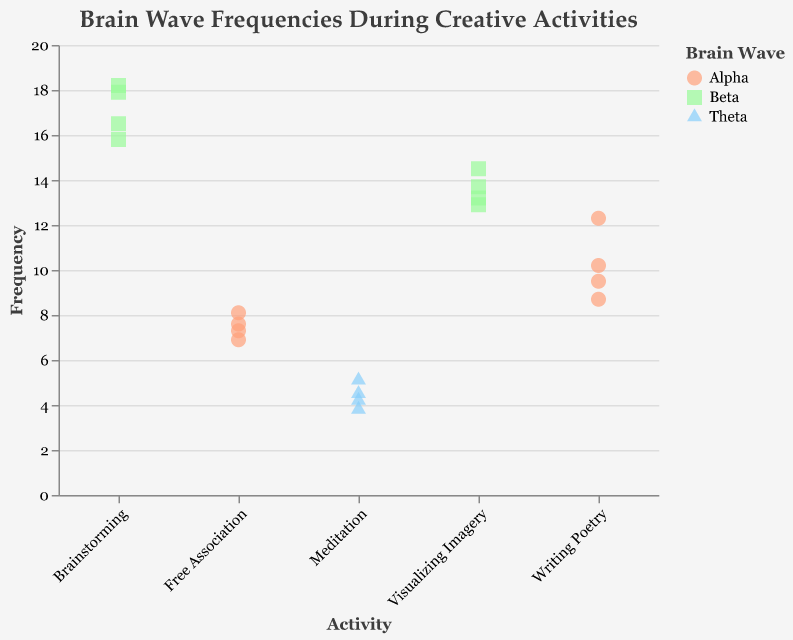What's the title of the figure? The title of the figure is typically found at the top and summarizes the main focus of the chart. Here, it reads "Brain Wave Frequencies During Creative Activities."
Answer: Brain Wave Frequencies During Creative Activities Which brain wave type is associated with the highest frequency during Brainstorming? By looking at the points plotted for Brainstorming, we can see the color and shape used for those points. The highest frequency is around 18.2, and these points are colored in green and are square-shaped. According to the legend, green squares represent Beta waves.
Answer: Beta How many data points are there in the activity Meditation? By counting the plotted points under the "Meditation" category on the x-axis, we can see there are four triangular points.
Answer: 4 Compare the average frequencies of Alpha waves in Writing Poetry and Free Association. Which activity has a lower average frequency of Alpha waves? First, calculate the average frequency for Writing Poetry ([10.2 + 8.7 + 12.3 + 9.5] / 4) and Free Association ([7.3 + 6.9 + 8.1 + 7.6] / 4). Writing Poetry average is (40.7 / 4) = 10.175; Free Association average is (29.9 / 4) = 7.475. Free Association has a lower average frequency.
Answer: Free Association What's the range of frequencies for the activity Visualizing Imagery? The range is the difference between the maximum and minimum values. The highest frequency for Visualizing Imagery is 14.5 and the lowest is 12.9. Thus, the range is 14.5 - 12.9.
Answer: 1.6 Which activity shows the most overlap in frequencies with Alpha and Beta brain waves? By observing the x-axis categories where both Alpha (circle) and Beta (square) points are present, it's evident that there's no single activity with both Alpha and Beta overlaps. All activities are separated by BrainWave type.
Answer: None Which activity has the lowest frequency recorded and what is the brain wave type? By scanning the y-axis values, the lowest frequency is 3.8 during the Meditation activity, which is represented by a blue triangle. According to the legend, this is a Theta wave.
Answer: Meditation, Theta What is the median frequency for the Free Association activity? To find the median, the frequencies for Free Association ([6.9, 7.3, 7.6, 8.1]) are arranged in ascending order. The median is the average of the two middle numbers (7.3 + 7.6) / 2.
Answer: 7.45 